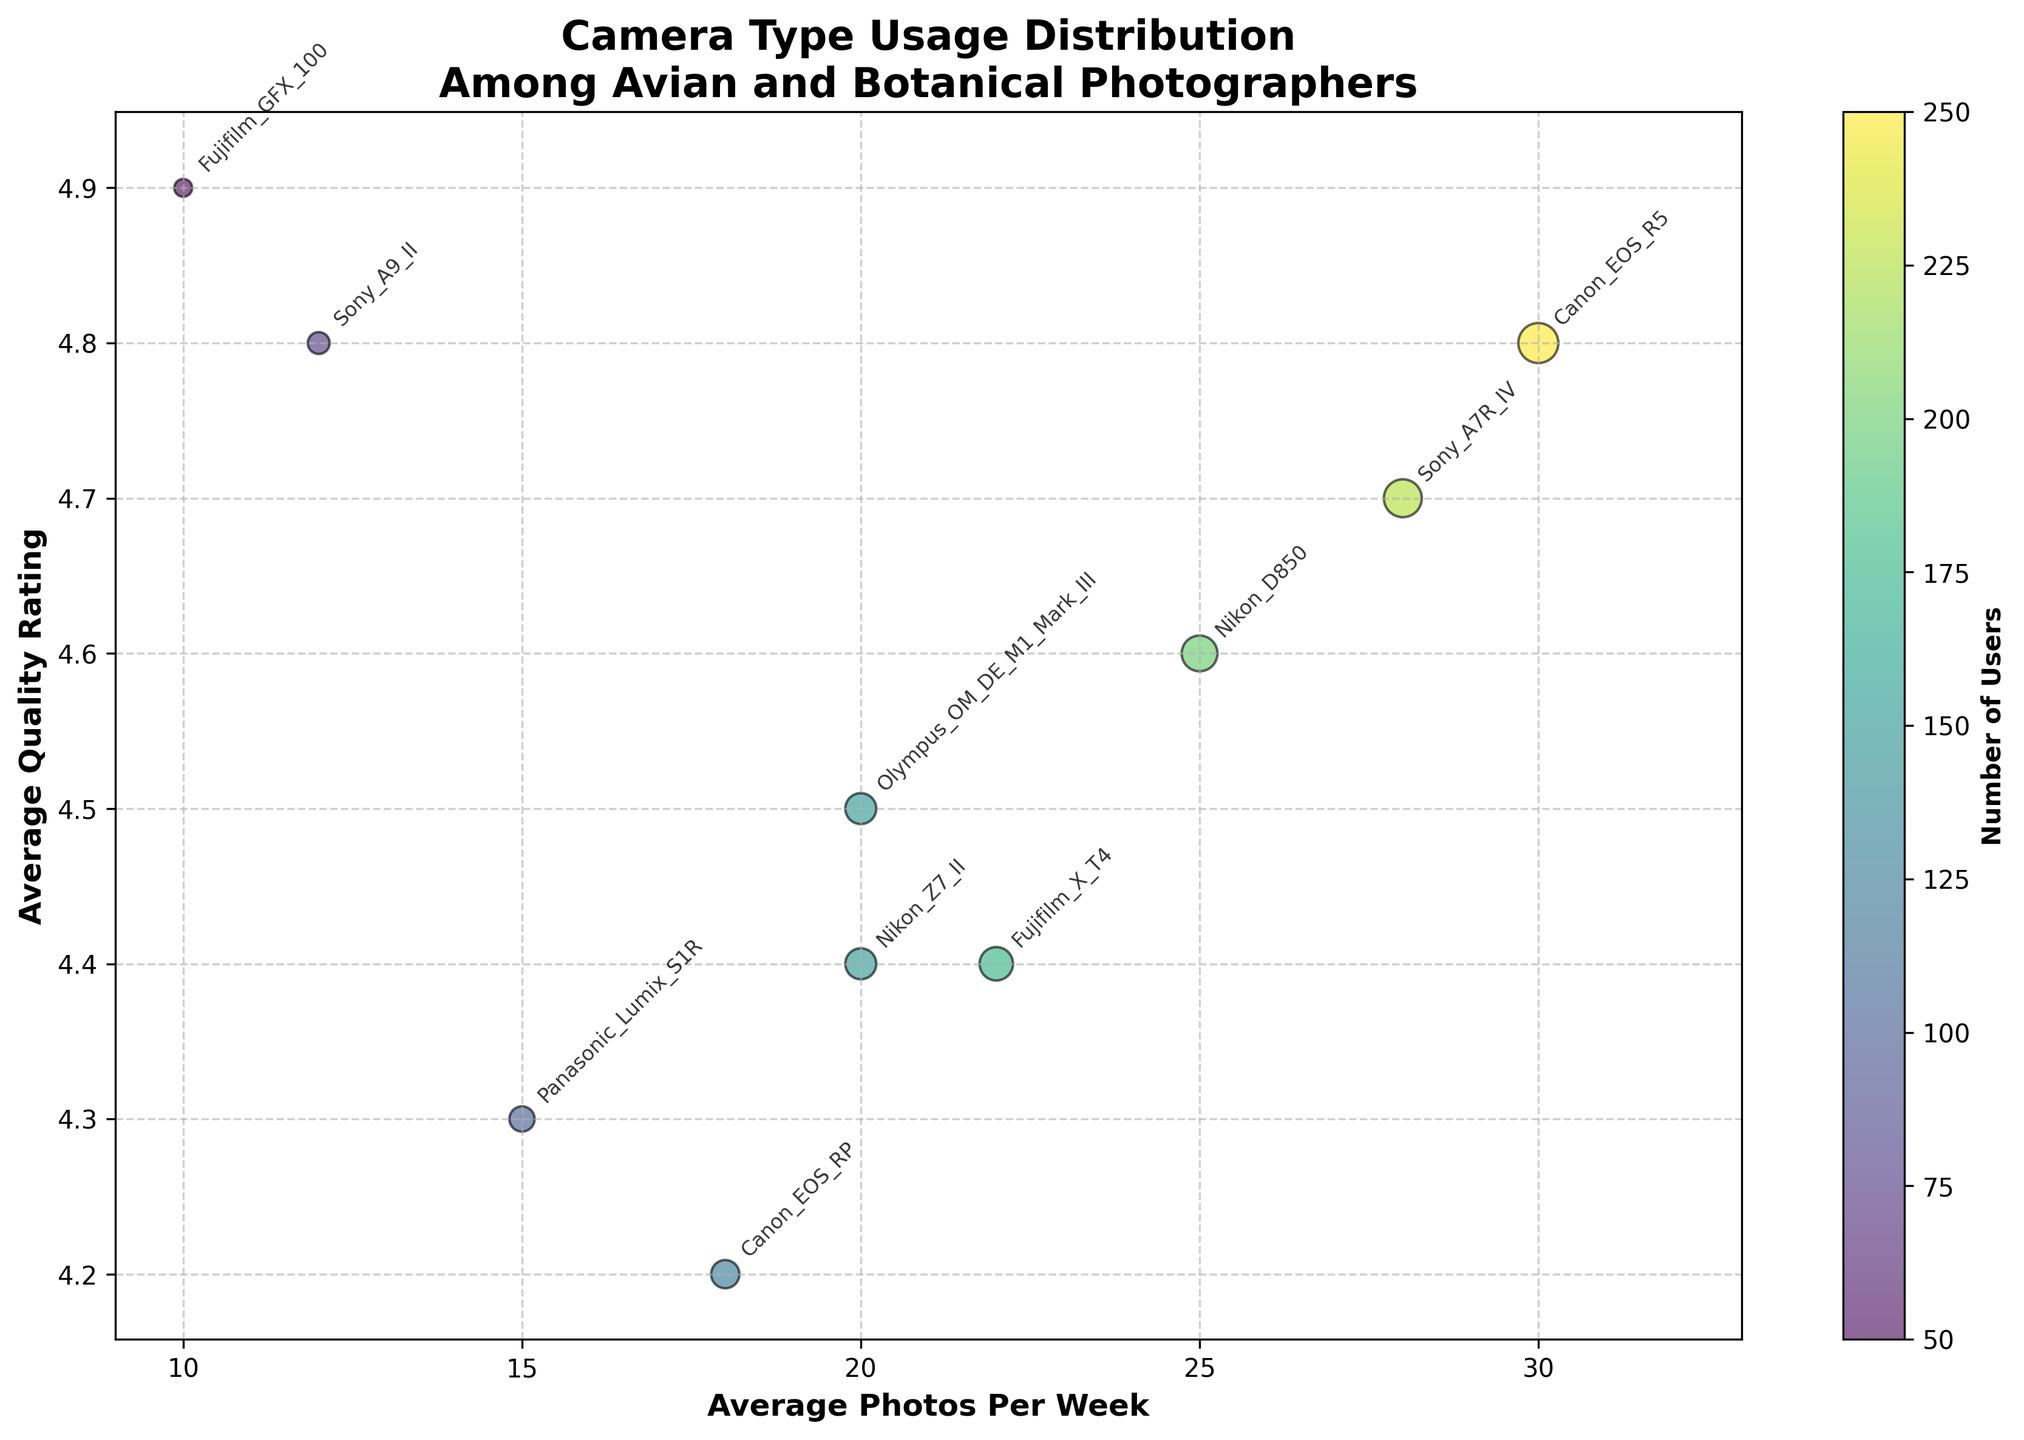What's the title of the bubble chart? The title of the chart is displayed prominently at the top of the figure. It gives an overview of what the chart represents. The title of the chart is 'Camera Type Usage Distribution Among Avian and Botanical Photographers'.
Answer: Camera Type Usage Distribution Among Avian and Botanical Photographers What does the x-axis represent? The x-axis represents the average number of photos taken per week by users of each camera type. This information is labeled directly below the x-axis in the plot.
Answer: Average Photos Per Week Which camera type has the highest photo quality rating? By looking at the y-axis (Average Quality Rating) and finding the highest point, we can see which camera type corresponds to that point. The camera type 'Fujifilm GFX 100' has the highest quality rating of 4.9.
Answer: Fujifilm GFX 100 Which camera model has the largest user base? The size of the bubbles represents the number of users. The Canon EOS R5 has the largest bubble, indicating it has the largest user base with 50 users.
Answer: Canon EOS R5 What is the average quality rating for 'Sony A7R IV'? Locate the bubble for the 'Sony A7R IV' and check its position along the y-axis. The average quality rating for the 'Sony A7R IV' is 4.7.
Answer: 4.7 Which camera has the fewest number of users? The size of the bubbles indicates the number of users. The smallest bubble represents the camera with the fewest users. The 'Fujifilm GFX 100' has the fewest number of users with 10.
Answer: Fujifilm GFX 100 What is the total number of users across all camera types? We calculate the total number of users by summing up the numbers provided for each camera type: (50 + 40 + 45 + 30 + 35 + 20 + 25 + 30 + 15 + 10) = 300.
Answer: 300 Which camera type has both high average quality rating and high average photos per week? We look for camera types that are positioned high on the y-axis and further to the right on the x-axis. The 'Canon EOS R5' has a high average quality rating (4.8) and a high number of photos per week (30).
Answer: Canon EOS R5 Which camera type has the highest number of photos taken per week with less than 4.5 average quality rating? We need to look for bubbles positioned below the 4.5 mark on the y-axis and then find the one farthest to the right on the x-axis. The 'Canon EOS RP' with 18 photos per week and a quality rating of 4.2 fits this condition.
Answer: Canon EOS RP 